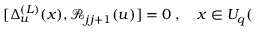<formula> <loc_0><loc_0><loc_500><loc_500>[ \Delta _ { u } ^ { ( L ) } ( x ) , \mathcal { R } _ { j j + 1 } ( u ) ] = 0 \, , \quad x \in U _ { q } (</formula> 